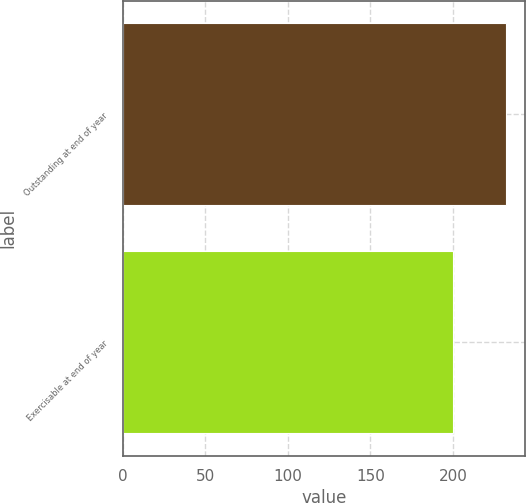Convert chart. <chart><loc_0><loc_0><loc_500><loc_500><bar_chart><fcel>Outstanding at end of year<fcel>Exercisable at end of year<nl><fcel>232<fcel>200<nl></chart> 